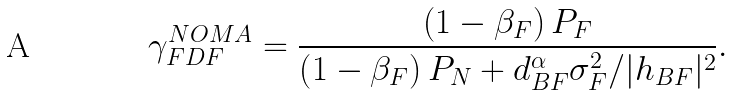<formula> <loc_0><loc_0><loc_500><loc_500>\gamma _ { F D F } ^ { N O M A } = \frac { \left ( 1 - \beta _ { F } \right ) P _ { F } } { \left ( 1 - \beta _ { F } \right ) P _ { N } + { d _ { B F } ^ { \alpha } \sigma _ { F } ^ { 2 } } / { | h _ { B F } | ^ { 2 } } } .</formula> 